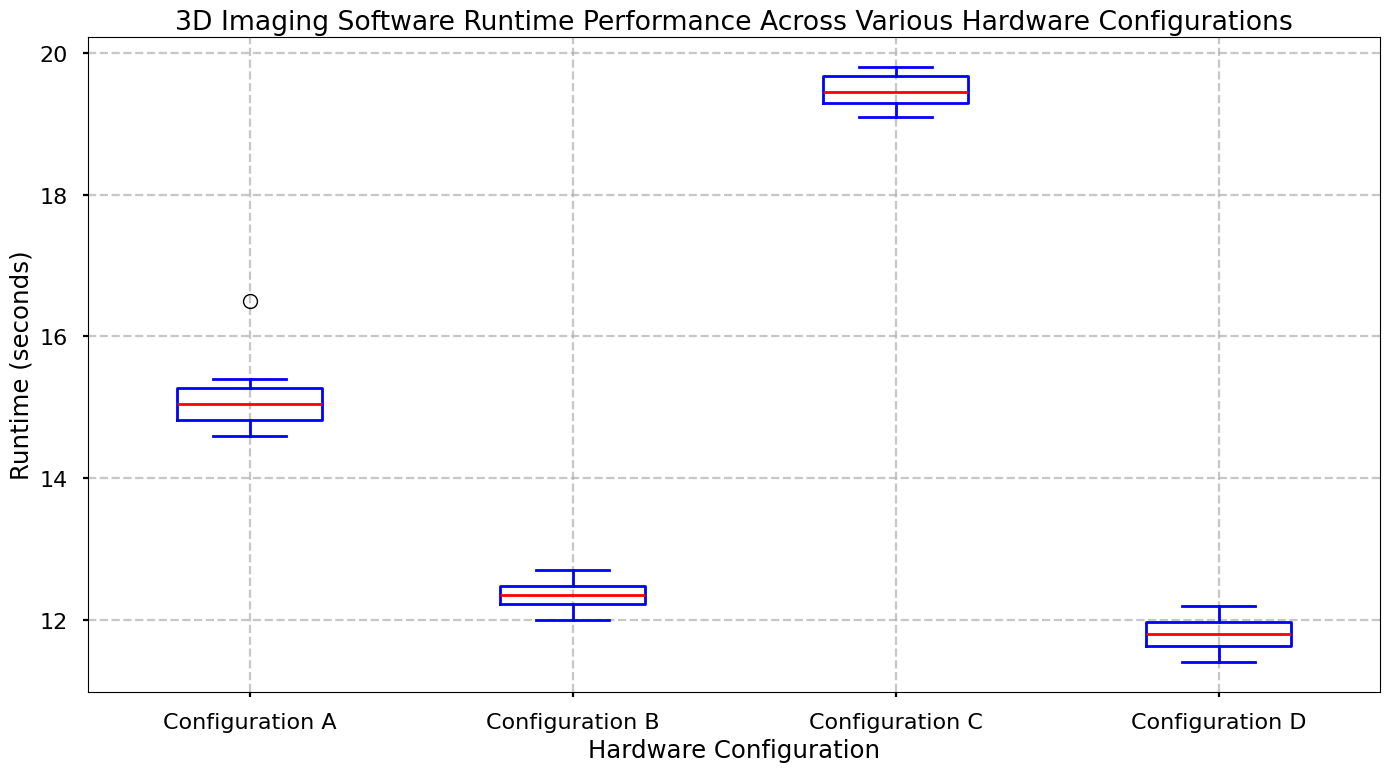Which hardware configuration has the lowest median runtime? The median runtime can be identified by the red line in each box. Configuration D has the lowest median runtime among all the configurations.
Answer: Configuration D How does the runtime variability of Configuration C compare to Configuration A? Runtime variability is shown by the interquartile range (IQR), which is the length of the box. Configuration C has a larger IQR than Configuration A, indicating higher variability.
Answer: Configuration C has higher variability What is the median runtime for Configuration B? The median runtime is represented by the red line inside the box plot. For Configuration B, the median runtime line is located slightly above 12.2 seconds.
Answer: Approximately 12.3 seconds Which hardware configuration shows the most consistent runtime performance? Consistency is indicated by the smallest IQR and minimal spread of the whiskers. Configuration D has the smallest IQR and whisker spread, indicating it is the most consistent.
Answer: Configuration D Compare the runtime performance between Configurations B and C. Which one generally performs better? A lower median runtime indicates better performance. Configuration B has a median runtime around 12.3 seconds, whereas Configuration C has a median runtime around 19.4 seconds; thus, Configuration B generally performs better.
Answer: Configuration B Which configuration has outliers, and how are they visually represented in the box plot? Outliers in box plots are represented by individual points outside the whiskers. Configuration A has outliers, shown as green dots below the box.
Answer: Configuration A Is there any configuration where the median is greater than the upper quartile of another configuration? Yes, compare the medians (red lines) and upper quartiles (top edge of the boxes). The median of Configuration C is greater than the upper quartiles of Configurations A, B, and D.
Answer: Yes, Configuration C What is the interquartile range (IQR) of Configuration A? The IQR is the difference between the third quartile (Q3) and the first quartile (Q1). From the box plot of Configuration A, Q3 is around 15.3 seconds and Q1 is around 14.8 seconds, so IQR = 15.3 - 14.8.
Answer: 0.5 seconds How do the whiskers of Configuration A compare with those of Configuration D? Whiskers represent the spread of the data within 1.5 times the IQR. Configuration A's whiskers are longer than those of Configuration D, indicating a wider spread in runtime.
Answer: Configuration A has longer whiskers 